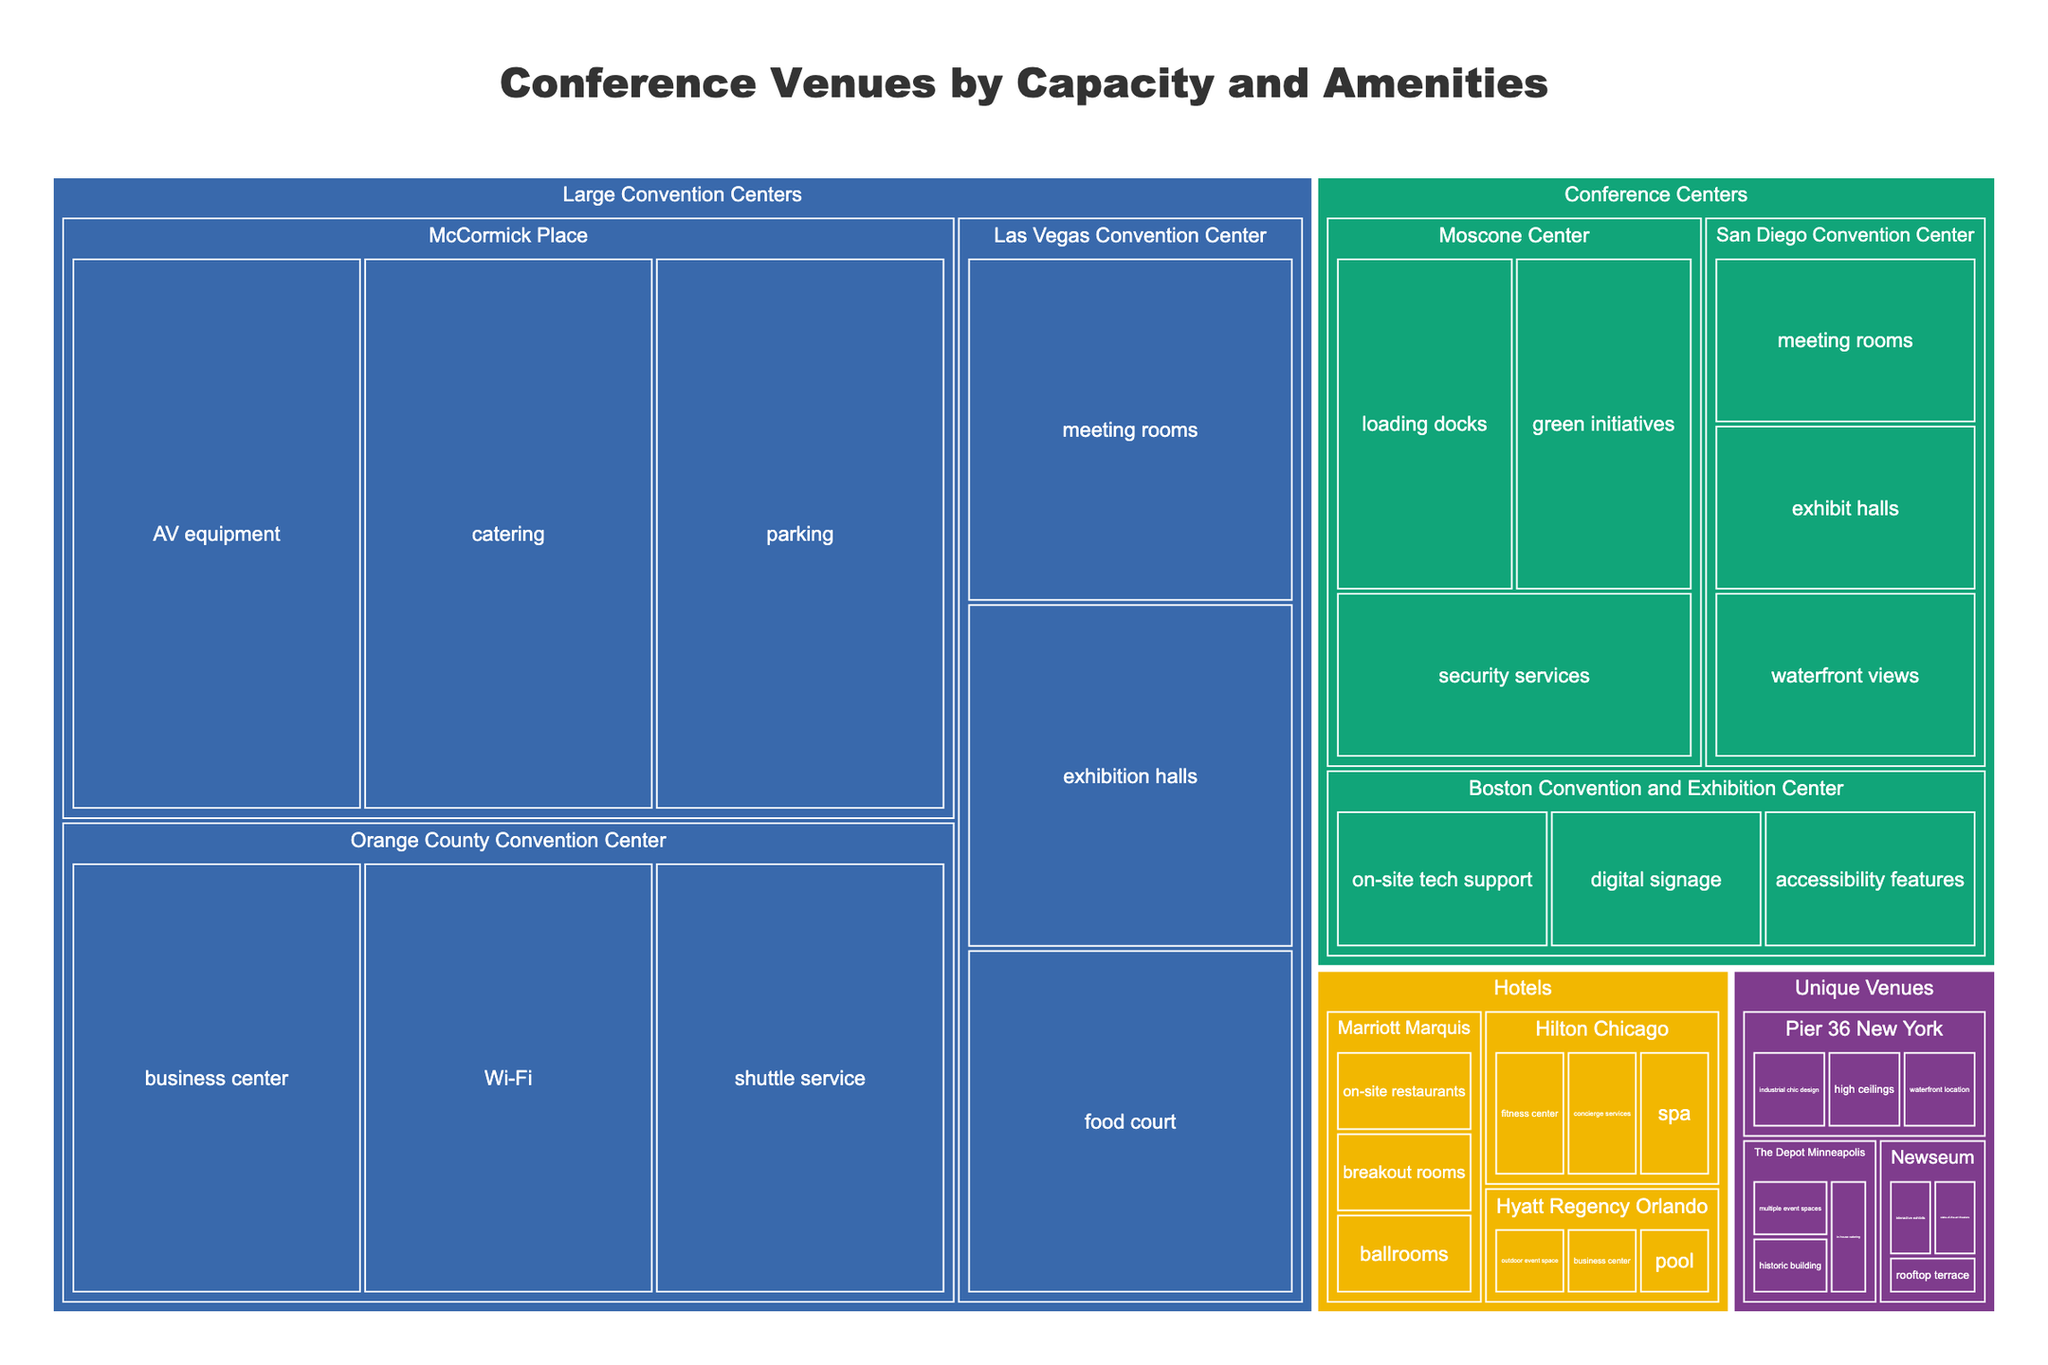How many categories of venues are shown? The treemap groups venues into distinct categories, indicated by the color-coded sections. We can count these distinct color-coded sections to determine the number of categories.
Answer: 4 What is the capacity of the McCormick Place venue? By examining the "Large Convention Centers" category in the treemap, we can locate "McCormick Place" and check its labeled capacity.
Answer: 50,000 Which venue has the highest capacity? The venue with the largest box within the treemap indicates the highest capacity. By comparing the sizes of the boxes, "McCormick Place" is the largest.
Answer: McCormick Place How does the capacity of the Marriott Marquis compare to the Hyatt Regency Orlando? Locate both "Marriott Marquis" and "Hyatt Regency Orlando" in the "Hotels" category, and compare their capacities. "Marriott Marquis" has a capacity of 5,000 and "Hyatt Regency Orlando" has a capacity of 3,000, so Marriott Marquis has a higher capacity.
Answer: Marriott Marquis has a higher capacity How is the data in the treemap organized? The treemap organizes data hierarchically by category, venue, and then amenities. Each level is nested within the previous one.
Answer: Hierarchically by category, venue, and amenities What are the amenities available at the Las Vegas Convention Center? Under the "Large Convention Centers" category, find "Las Vegas Convention Center" and check its listed amenities.
Answer: Exhibition halls, meeting rooms, food court Which category has the smallest total capacity? To find this, sum the capacities of venues in each category and compare. The "Unique Venues" category has the smallest total capacity: Pier 36 New York (3,500) + The Depot Minneapolis (2,500) + Newseum (2,000) = 8,000.
Answer: Unique Venues Which unique venue offers waterfront location as an amenity? Within the "Unique Venues" category, check which venue lists "waterfront location" as an amenity. "Pier 36 New York" has this amenity.
Answer: Pier 36 New York What is the combined capacity of all hotels in the treemap? Sum the capacities of all venues under the "Hotels" category: Marriott Marquis (5,000) + Hilton Chicago (4,500) + Hyatt Regency Orlando (3,000) = 12,500.
Answer: 12,500 